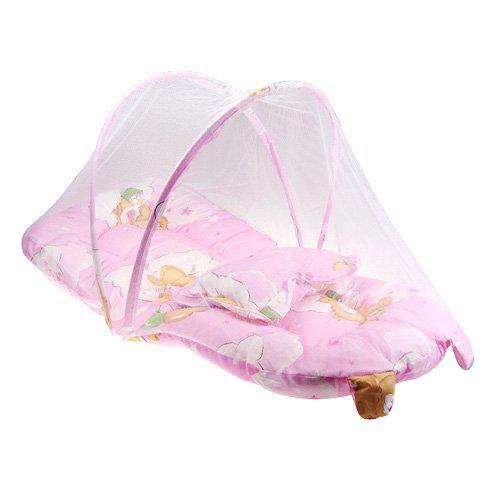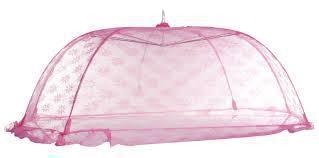The first image is the image on the left, the second image is the image on the right. Given the left and right images, does the statement "In one image, the baby bed is solid pink and has a shell cover over one end." hold true? Answer yes or no. No. 